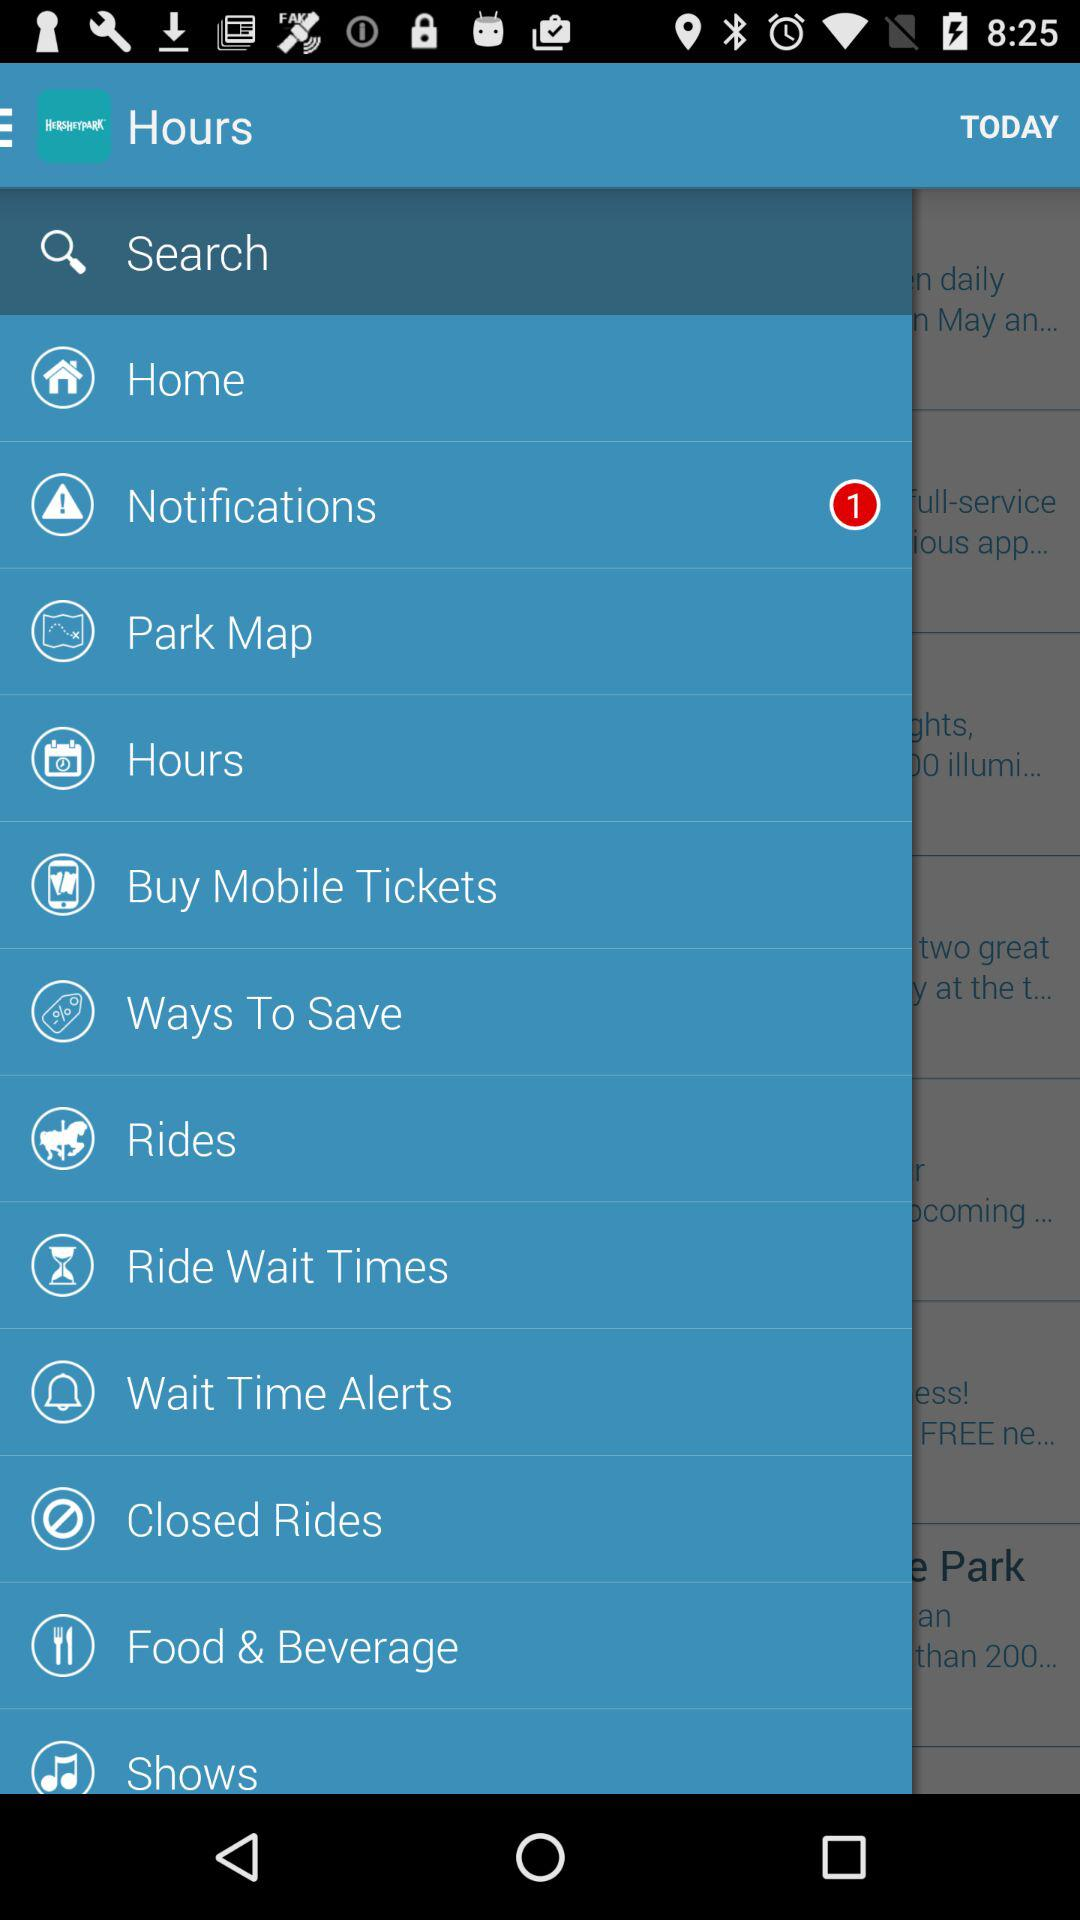How many unread notifications are there? There is 1 unread notification. 